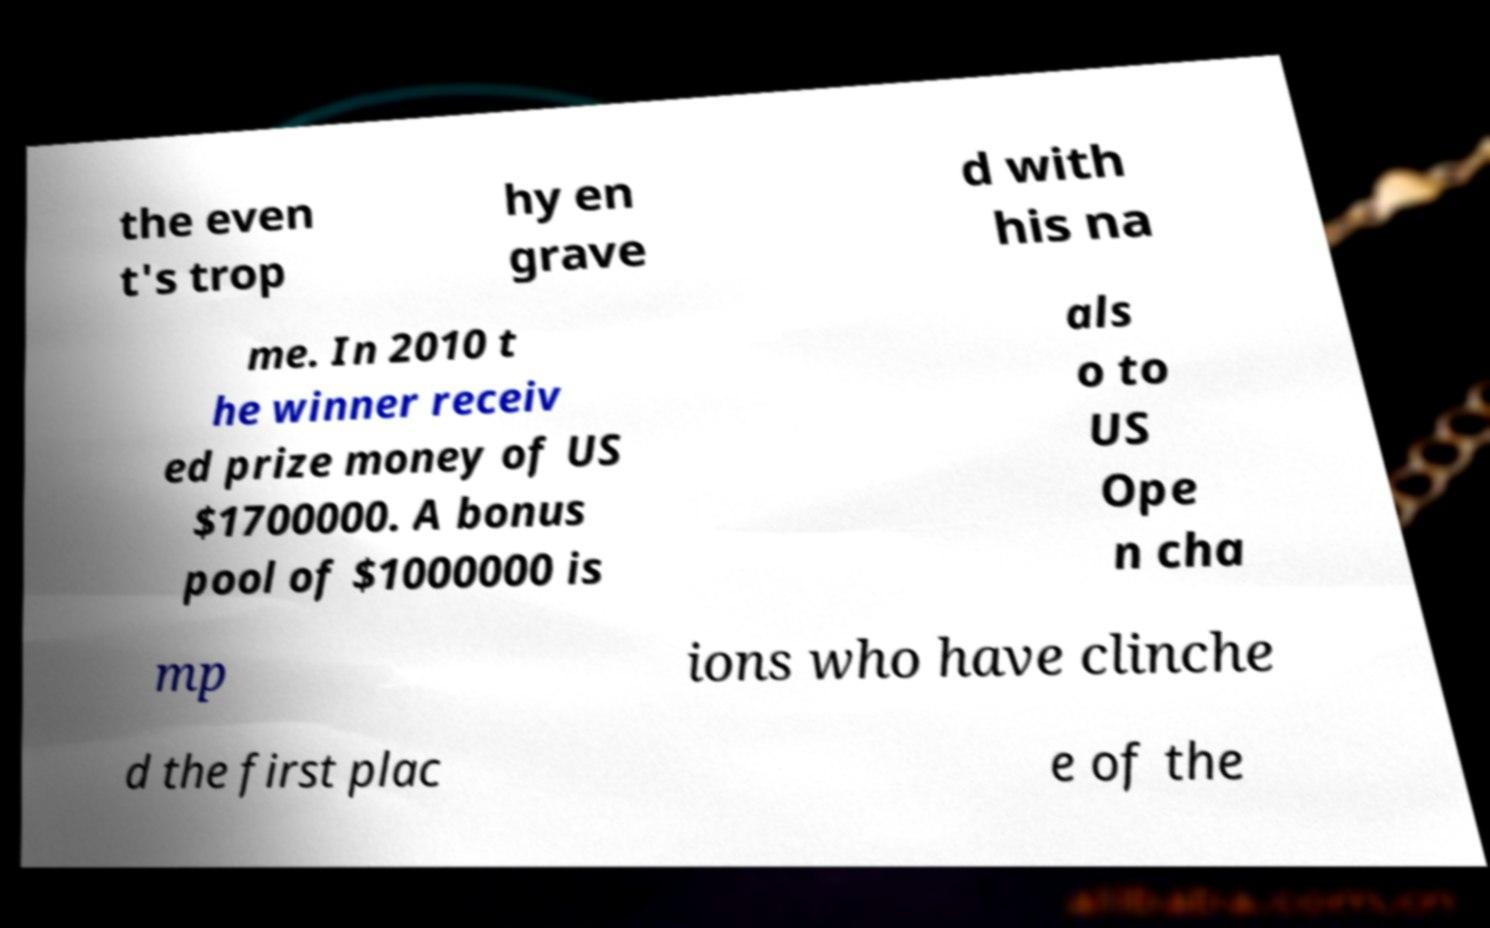Could you assist in decoding the text presented in this image and type it out clearly? the even t's trop hy en grave d with his na me. In 2010 t he winner receiv ed prize money of US $1700000. A bonus pool of $1000000 is als o to US Ope n cha mp ions who have clinche d the first plac e of the 